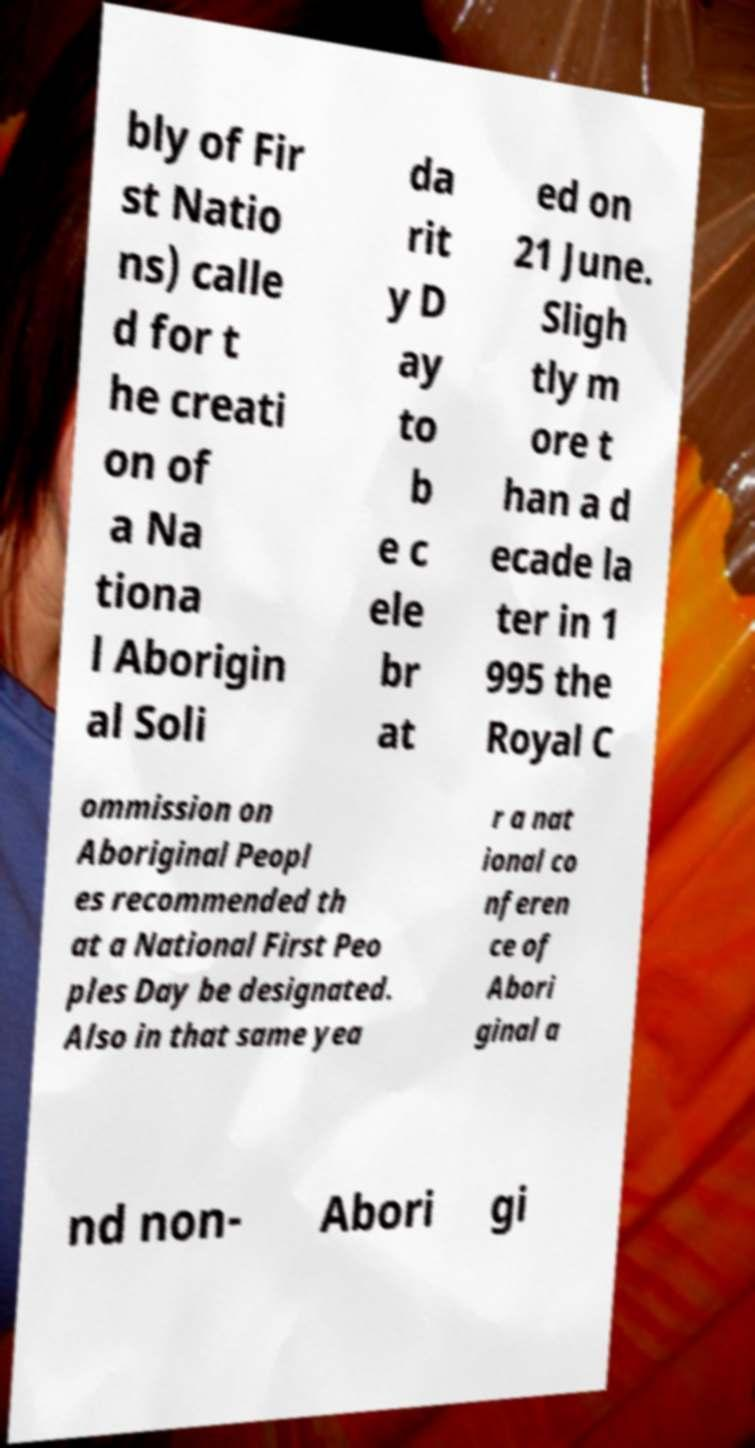Can you accurately transcribe the text from the provided image for me? bly of Fir st Natio ns) calle d for t he creati on of a Na tiona l Aborigin al Soli da rit y D ay to b e c ele br at ed on 21 June. Sligh tly m ore t han a d ecade la ter in 1 995 the Royal C ommission on Aboriginal Peopl es recommended th at a National First Peo ples Day be designated. Also in that same yea r a nat ional co nferen ce of Abori ginal a nd non- Abori gi 